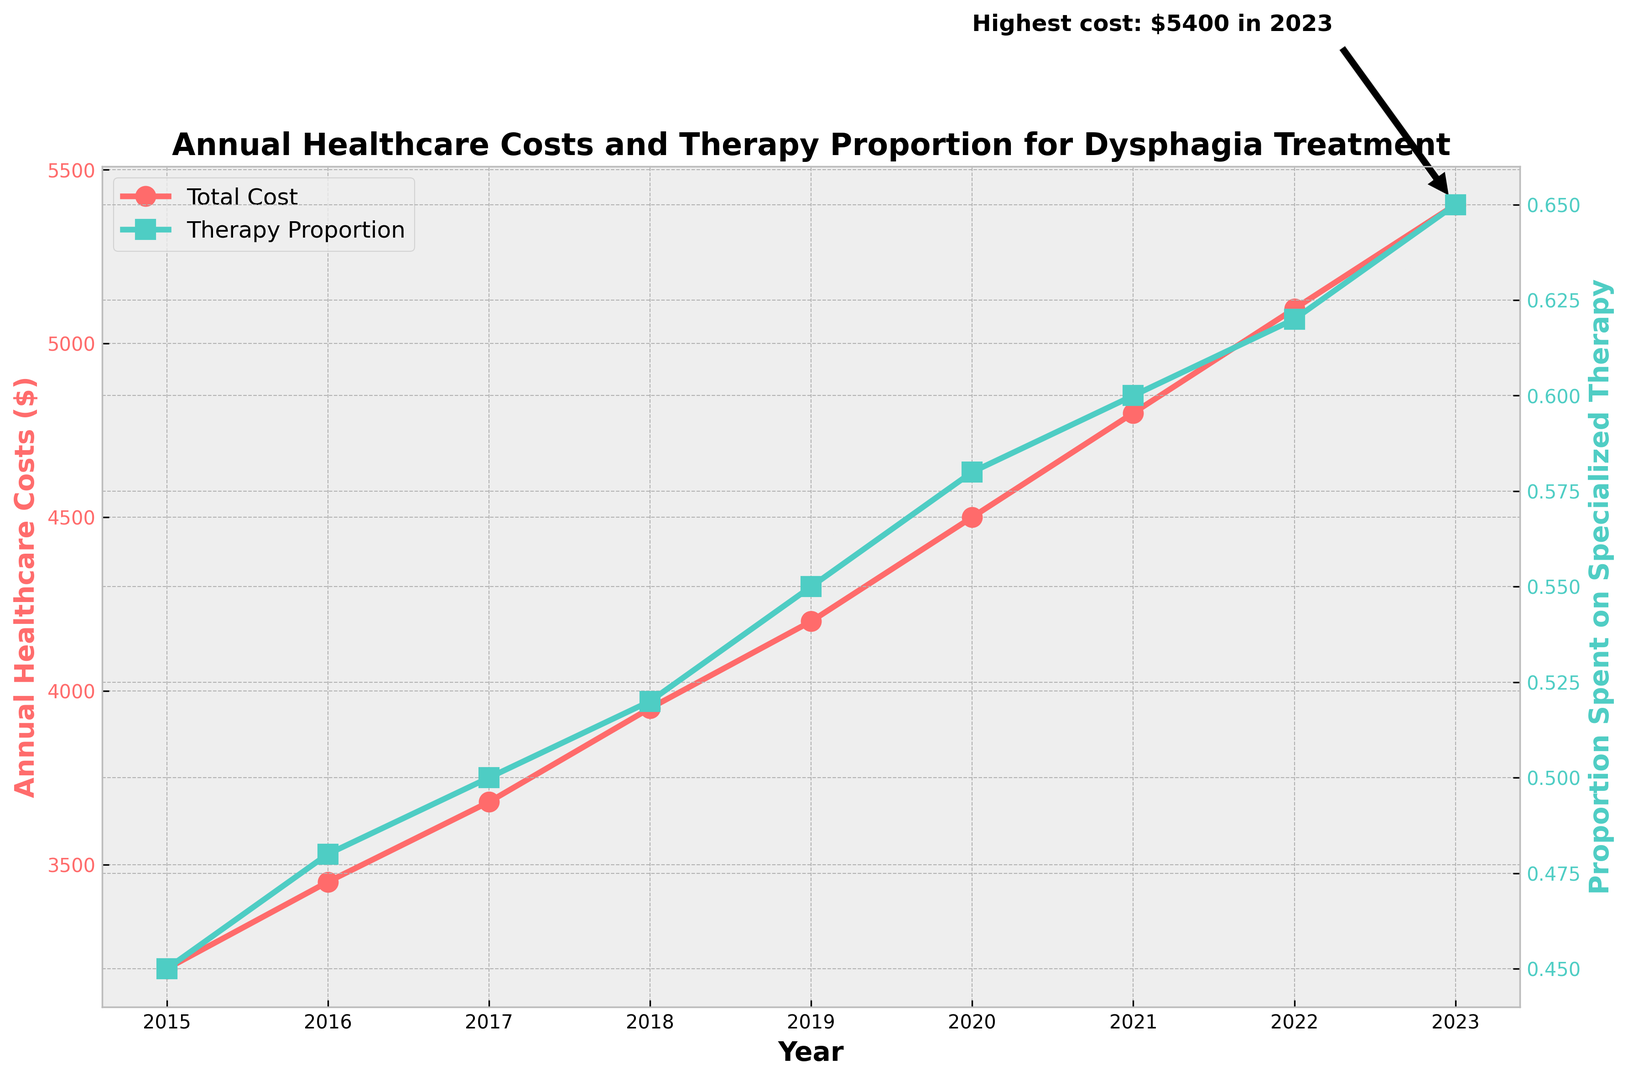What was the highest annual healthcare cost for dysphagia treatment, and in which year did it occur? The highest annual healthcare cost can be determined by looking at the annotated point on the plot with the largest dollar amount. The annotation highlights that the highest cost was $5400 in 2023.
Answer: $5400 in 2023 Which year had the lowest proportion of healthcare costs spent on specialized therapy, and what was the proportion? The smallest proportion can be found at the lowest point of the green line representing the therapy proportion plot. The year 2015 had the lowest proportion, which was 0.45.
Answer: 2015, 0.45 By how much did the annual healthcare cost for dysphagia treatment increase from 2015 to 2023? The cost in 2015 was $3200, and it increased to $5400 in 2023. The increase is calculated by subtracting the 2015 cost from the 2023 cost: $5400 - $3200 = $2200.
Answer: $2200 What was the average annual healthcare cost for dysphagia treatment between 2015 and 2023? To find the average, add up all the annual healthcare costs from 2015 to 2023 and divide by the number of years: (3200 + 3450 + 3680 + 3950 + 4200 + 4500 + 4800 + 5100 + 5400) / 9 = 40,280 / 9 ≈ 4475.
Answer: ≈ $4475 Which year saw the highest increase in the proportion of healthcare costs spent on specialized therapy compared to the previous year? Calculate the year-over-year increases in therapy proportion for each year and find the maximum. The increases are 0.03 (2015 to 2016), 0.02 (2016 to 2017), 0.02 (2017 to 2018), 0.03 (2018 to 2019), 0.03 (2019 to 2020), 0.02 (2020 to 2021), 0.02 (2021 to 2022), and 0.03 (2022 to 2023). The highest increase is 0.03, which occurs in 2015 to 2016, 2018 to 2019, and 2022 to 2023.
Answer: 2015 to 2016, 2018 to 2019, 2022 to 2023 In which year did the total annual healthcare cost first exceed $4000? Look at the red line denoting annual healthcare costs and find the first year it crosses the $4000 mark. The cost first exceeds $4000 in 2019.
Answer: 2019 What is the difference in the proportion of healthcare costs spent on specialized therapy between 2015 and 2023? The proportion in 2015 was 0.45 and in 2023 it was 0.65. Subtract the 2015 proportion from the 2023 proportion: 0.65 - 0.45 = 0.20.
Answer: 0.20 How does the therapy proportion in 2017 compare to the therapy proportion in 2020? The therapy proportion in 2017 was 0.50, and in 2020 it was 0.58. The therapy proportion in 2020 is greater than in 2017.
Answer: 2020 is greater than 2017 